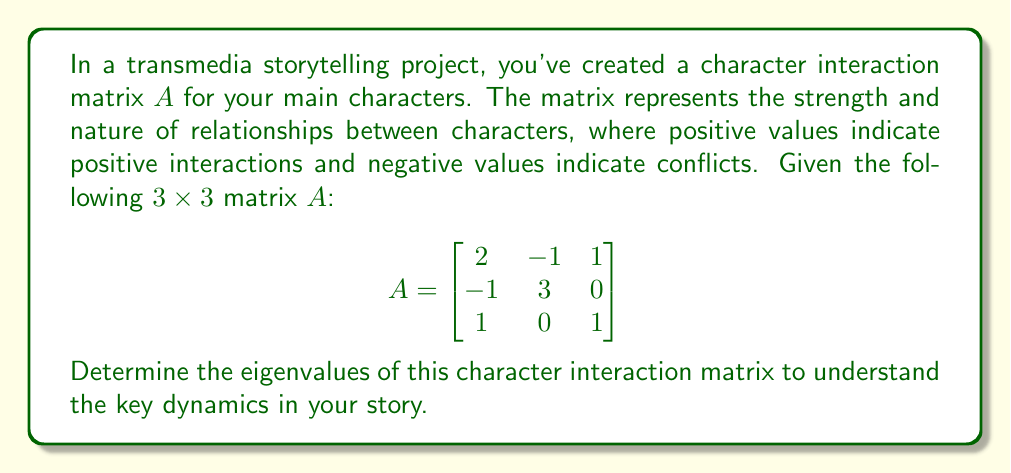Solve this math problem. To find the eigenvalues of matrix $A$, we need to solve the characteristic equation:

1) First, we set up the equation $\det(A - \lambda I) = 0$, where $I$ is the $3 \times 3$ identity matrix and $\lambda$ represents the eigenvalues:

   $$\det\begin{pmatrix}
   2-\lambda & -1 & 1 \\
   -1 & 3-\lambda & 0 \\
   1 & 0 & 1-\lambda
   \end{pmatrix} = 0$$

2) Expand the determinant:
   $$(2-\lambda)[(3-\lambda)(1-\lambda) - 0] + (-1)[(-1)(1-\lambda) - 1(3-\lambda)] + 1[(-1)(0) - (-1)(1-\lambda)] = 0$$

3) Simplify:
   $$(2-\lambda)(3-\lambda)(1-\lambda) + (1-\lambda) + (3-\lambda) = 0$$

4) Expand further:
   $$6 - 3\lambda - 2\lambda + \lambda^2 - 3\lambda + \lambda^2 + \lambda^3 + 1 - \lambda + 3 - \lambda = 0$$

5) Collect terms:
   $$\lambda^3 - 4\lambda^2 - \lambda + 10 = 0$$

6) This cubic equation can be factored as:
   $$(\lambda - 2)(\lambda^2 - 2\lambda - 5) = 0$$

7) Solve the quadratic part using the quadratic formula:
   $$\lambda = \frac{2 \pm \sqrt{4 + 20}}{2} = \frac{2 \pm \sqrt{24}}{2} = \frac{2 \pm 2\sqrt{6}}{2} = 1 \pm \sqrt{6}$$

Therefore, the eigenvalues are:
$\lambda_1 = 2$, $\lambda_2 = 1 + \sqrt{6}$, and $\lambda_3 = 1 - \sqrt{6}$
Answer: $\lambda_1 = 2$, $\lambda_2 = 1 + \sqrt{6}$, $\lambda_3 = 1 - \sqrt{6}$ 